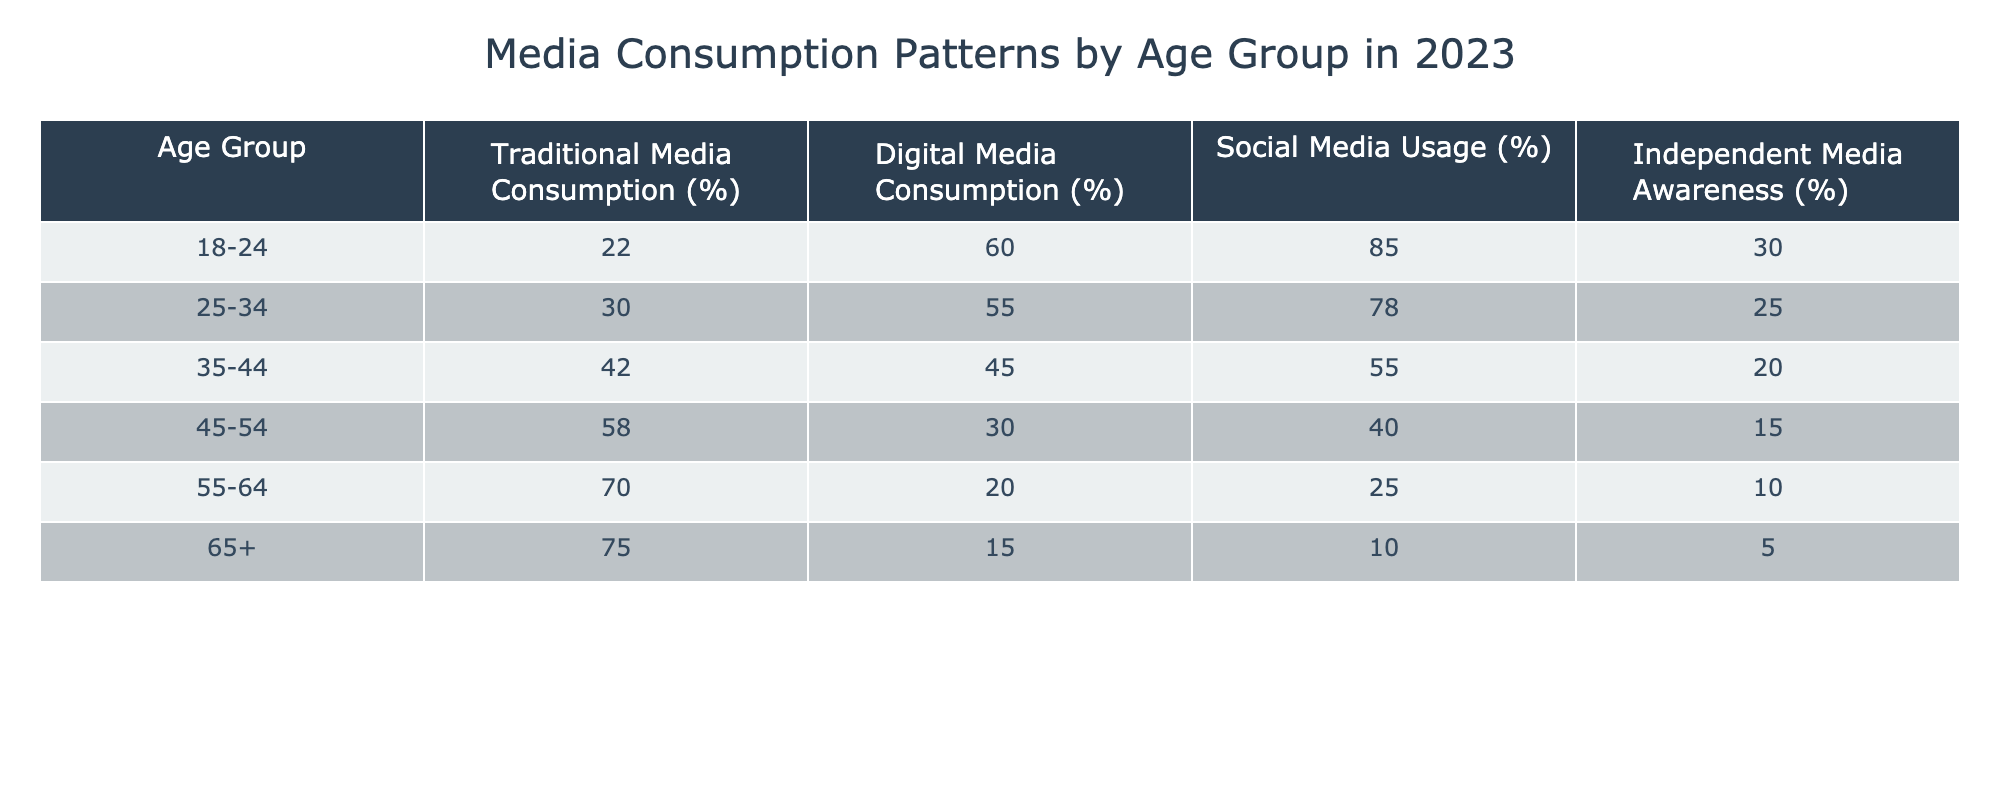What is the percentage of digital media consumption for the 25-34 age group? The table states that the digital media consumption for the 25-34 age group is 55%.
Answer: 55% Which age group has the highest percentage of traditional media consumption? From the table, the age group with the highest traditional media consumption is 65+ at 75%.
Answer: 65+ Is it true that independent media awareness decreases consistently as age increases? Looking at the table, the independent media awareness decreases from 30% in the 18-24 age group to 5% in the 65+ age group, indicating a consistent decrease.
Answer: Yes What is the average percentage of social media usage across all age groups? To find the average, sum the percentages of social media usage: (85 + 78 + 55 + 40 + 25 + 10) = 293. There are 6 age groups, so the average is 293/6 = approximately 48.83%.
Answer: Approximately 48.83% In which age group is traditional media consumption lowest? The data shows that the 55-64 age group has the lowest traditional media consumption percentage at 70%.
Answer: 55-64 What is the difference in digital media consumption between the 18-24 and 45-54 age groups? The digital media consumption for the 18-24 age group is 60% and for the 45-54 age group is 30%. The difference is 60% - 30% = 30%.
Answer: 30% Which age group has a greater awareness of independent media: 35-44 or 45-54? From the table, the 35-44 age group has 20% awareness of independent media, while the 45-54 age group has 15%. Thus, 35-44 has greater awareness.
Answer: 35-44 What is the total percentage of traditional media consumption for the two youngest age groups (18-24 and 25-34)? The traditional media consumption for 18-24 is 22% and for 25-34 is 30%. The total is 22% + 30% = 52%.
Answer: 52% 